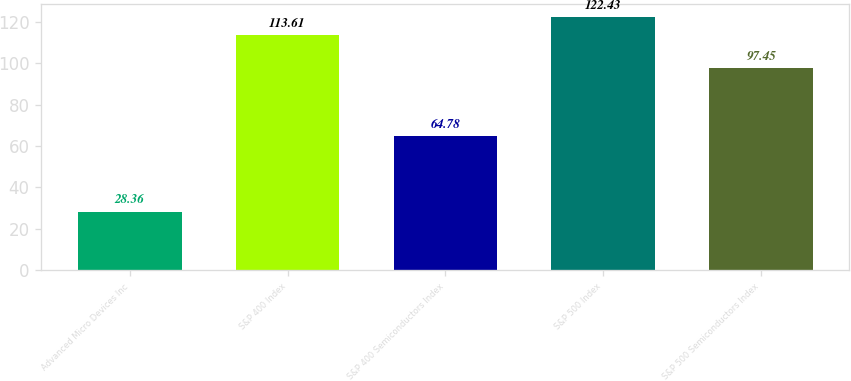Convert chart to OTSL. <chart><loc_0><loc_0><loc_500><loc_500><bar_chart><fcel>Advanced Micro Devices Inc<fcel>S&P 400 Index<fcel>S&P 400 Semiconductors Index<fcel>S&P 500 Index<fcel>S&P 500 Semiconductors Index<nl><fcel>28.36<fcel>113.61<fcel>64.78<fcel>122.43<fcel>97.45<nl></chart> 